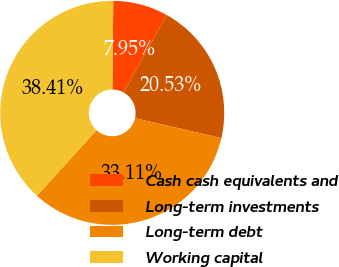Convert chart. <chart><loc_0><loc_0><loc_500><loc_500><pie_chart><fcel>Cash cash equivalents and<fcel>Long-term investments<fcel>Long-term debt<fcel>Working capital<nl><fcel>7.95%<fcel>20.53%<fcel>33.11%<fcel>38.41%<nl></chart> 